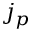Convert formula to latex. <formula><loc_0><loc_0><loc_500><loc_500>j _ { p }</formula> 